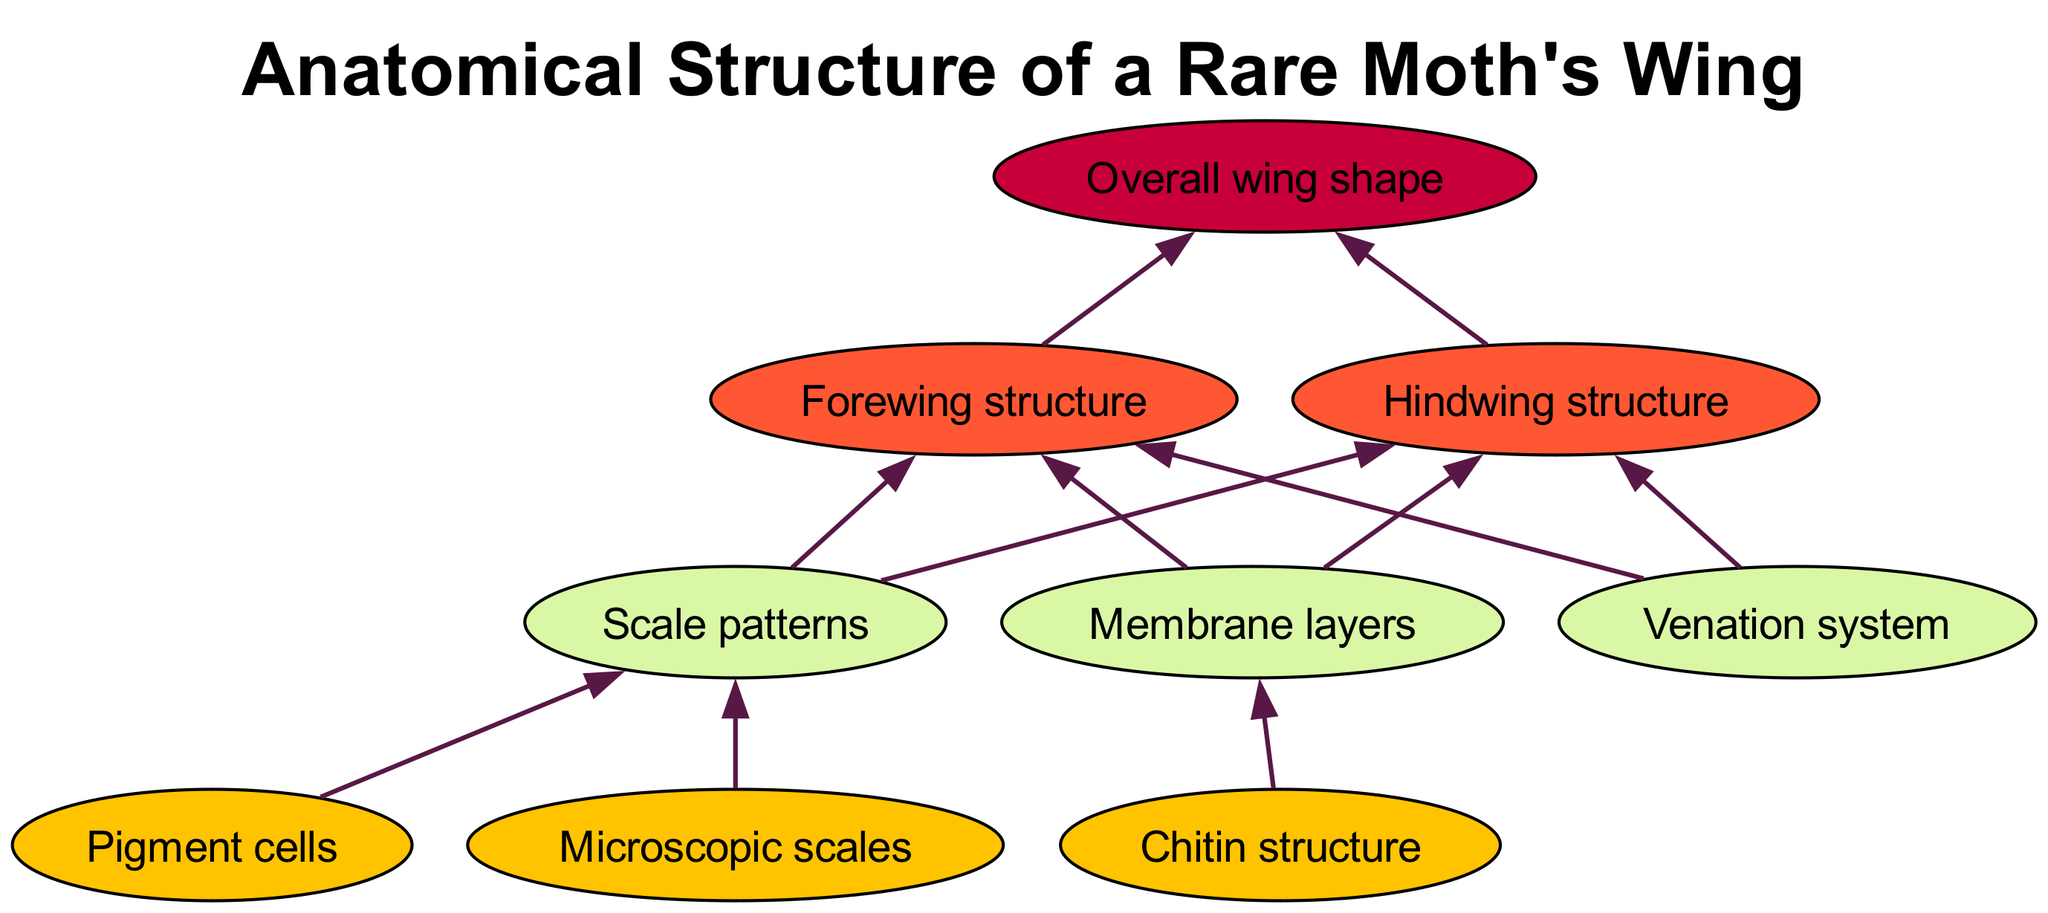What are the items at level 1? The items in level 1 of the diagram, which represent the microscopic components of the moth's wing, include "Microscopic scales," "Chitin structure," and "Pigment cells."
Answer: Microscopic scales, Chitin structure, Pigment cells How many nodes are there in the diagram? By counting all the unique items at each level, which includes 3 items at level 1, 3 items at level 2, 2 items at level 3, and 1 item at level 4, there is a total of 9 nodes.
Answer: 9 What is the direct relationship between 'Pigment cells' and 'Forewing structure'? 'Pigment cells' connect to 'Scale patterns,' which in turn connect to both 'Forewing structure' and 'Hindwing structure.' Therefore, 'Pigment cells' influence 'Forewing structure' indirectly.
Answer: Indirectly through Scale patterns Which item directly leads to 'Overall wing shape'? Both 'Forewing structure' and 'Hindwing structure' directly lead to the 'Overall wing shape' in the diagram, indicating their contribution to the final shape of the wing.
Answer: Forewing structure, Hindwing structure What level has a connection to 'Venation system'? The 'Venation system' is at level 2, as it is responsible for connecting to both 'Forewing structure' and 'Hindwing structure' at level 3, showing its importance in the wing's anatomy.
Answer: Level 2 How many connections lead from 'Microscopic scales'? There are two connections leading from 'Microscopic scales': one to 'Scale patterns' and another indirectly affecting 'Hindwing structure' through 'Scale patterns.'
Answer: 1 What is the last structure leading to 'Overall wing shape'? The last structures that lead to 'Overall wing shape' are 'Forewing structure' and 'Hindwing structure,' both of which culminate in the final wing shape.
Answer: Forewing structure, Hindwing structure Which level contains 'Membrane layers'? 'Membrane layers' are found in level 2, where they connect to both 'Forewing structure' and 'Hindwing structure.' This indicates their structural role in the wing anatomy.
Answer: Level 2 What is the first level in the diagram? The first level in the diagram is level 1, representing the most basic anatomical components of the moth's wing before they contribute to higher structures.
Answer: Level 1 